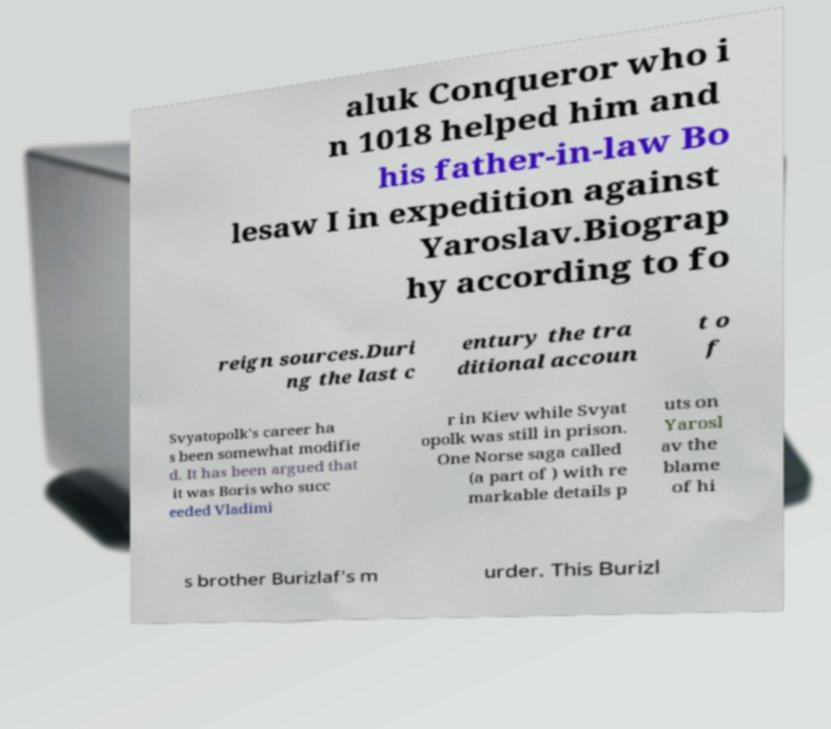Please identify and transcribe the text found in this image. aluk Conqueror who i n 1018 helped him and his father-in-law Bo lesaw I in expedition against Yaroslav.Biograp hy according to fo reign sources.Duri ng the last c entury the tra ditional accoun t o f Svyatopolk's career ha s been somewhat modifie d. It has been argued that it was Boris who succ eeded Vladimi r in Kiev while Svyat opolk was still in prison. One Norse saga called (a part of ) with re markable details p uts on Yarosl av the blame of hi s brother Burizlaf's m urder. This Burizl 